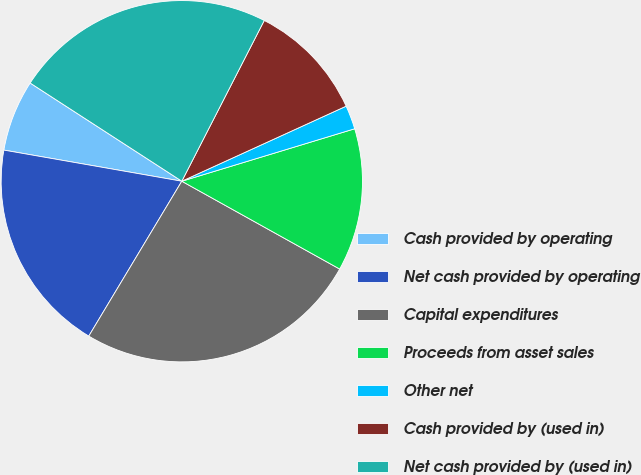Convert chart. <chart><loc_0><loc_0><loc_500><loc_500><pie_chart><fcel>Cash provided by operating<fcel>Net cash provided by operating<fcel>Capital expenditures<fcel>Proceeds from asset sales<fcel>Other net<fcel>Cash provided by (used in)<fcel>Net cash provided by (used in)<nl><fcel>6.39%<fcel>19.15%<fcel>25.53%<fcel>12.77%<fcel>2.13%<fcel>10.64%<fcel>23.4%<nl></chart> 